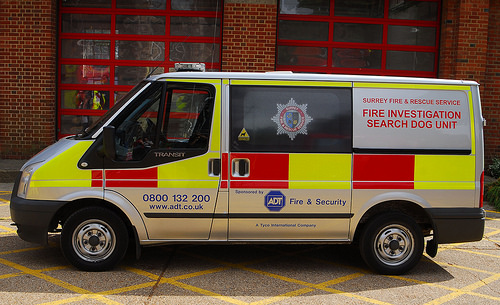<image>
Can you confirm if the car is under the building? No. The car is not positioned under the building. The vertical relationship between these objects is different. 